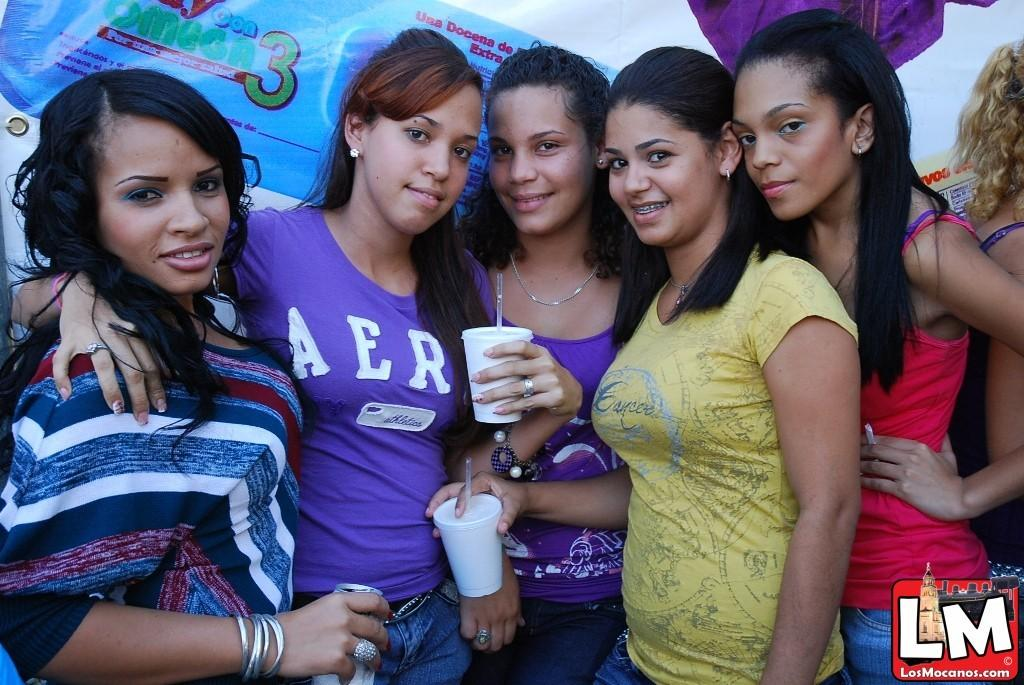What can be seen in the image? There is a group of people in the image. How are the people dressed? The people are wearing different color dresses. What are some people holding in the image? Some people are holding cups. What is visible in the background of the image? There is a banner in the background of the image. What type of railway is visible in the image? There is no railway present in the image. How does the police presence affect the mood of the people in the image? There is no police presence in the image, so it cannot affect the mood of the people. 